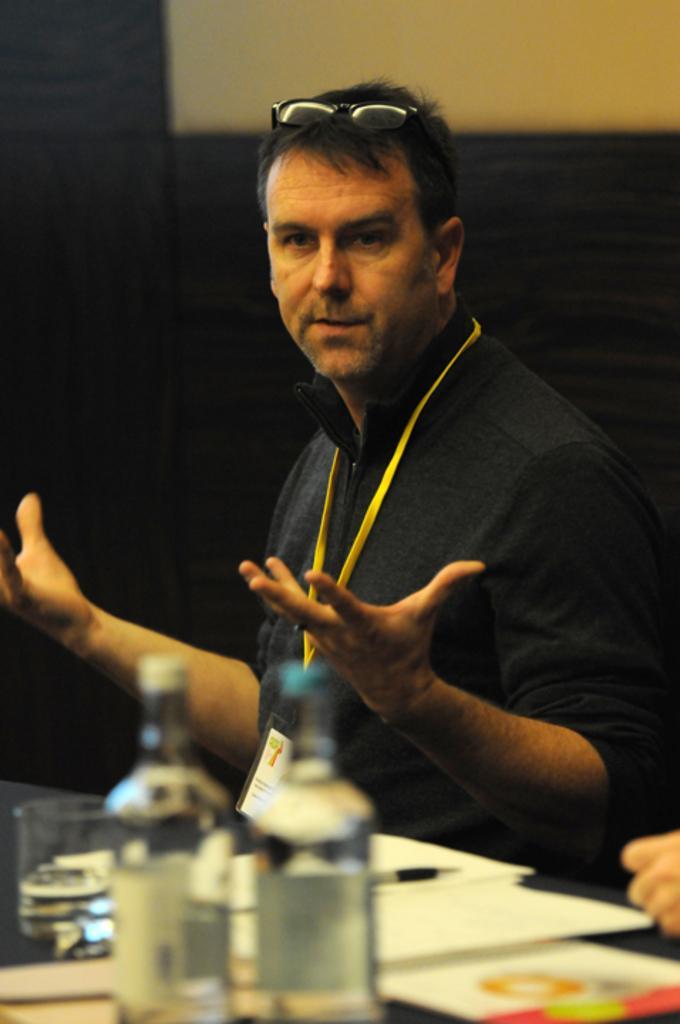Please provide a concise description of this image. In this image we can see a person sitting near the table and on the table there are bottles, glass, papers and a pen and wall in the background. 